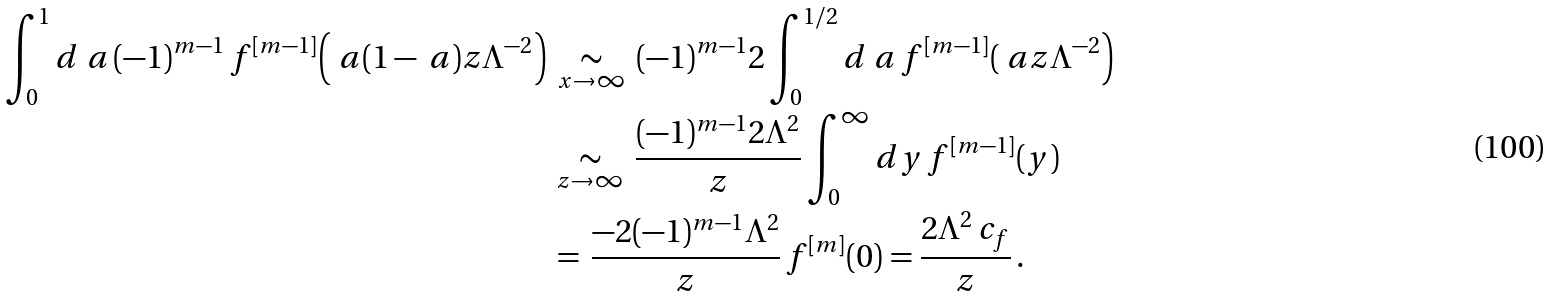Convert formula to latex. <formula><loc_0><loc_0><loc_500><loc_500>\int _ { 0 } ^ { 1 } d \ a \, ( - 1 ) ^ { m - 1 } \, f ^ { [ m - 1 ] } \Big ( \ a ( 1 - \ a ) z \Lambda ^ { - 2 } \Big ) & \, \underset { x \to \infty } { \sim } \, ( - 1 ) ^ { m - 1 } 2 \int _ { 0 } ^ { 1 / 2 } d \ a \, f ^ { [ m - 1 ] } ( \ a z \Lambda ^ { - 2 } \Big ) \\ & \, \underset { z \to \infty } { \sim } \, \frac { ( - 1 ) ^ { m - 1 } 2 \Lambda ^ { 2 } } { z } \int _ { 0 } ^ { \infty } d y \, f ^ { [ m - 1 ] } ( y ) \\ & \, \underset { \, } { = \, } \frac { - 2 ( - 1 ) ^ { m - 1 } \Lambda ^ { 2 } } { z } \, f ^ { [ m ] } ( 0 ) = \frac { 2 \Lambda ^ { 2 } \, c _ { f } } { z } \, .</formula> 